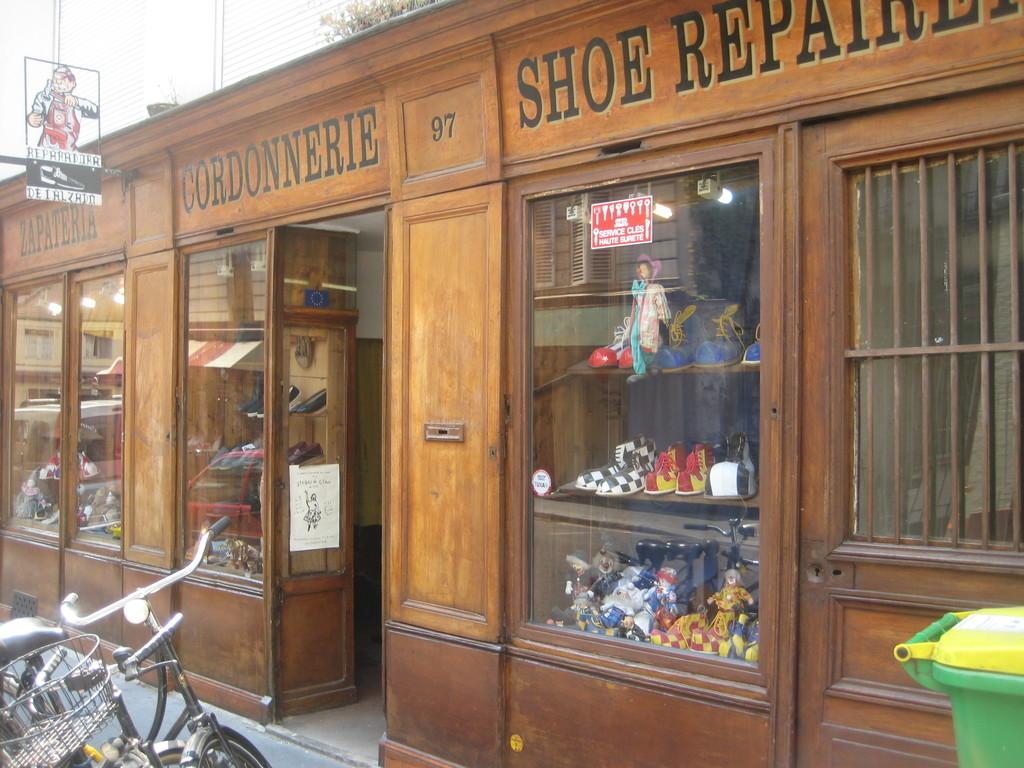What can be seen on the left side of the image? There is a bicycle on the left side of the image. What is visible in the background of the image? There is a building with text in the background of the image. What is the purpose of the mirror in the image? The mirror allows us to see objects visible behind it in the image. How does the bicycle show respect to the building in the image? The bicycle does not show respect to the building in the image, as it is an inanimate object and cannot display emotions or actions related to respect. 